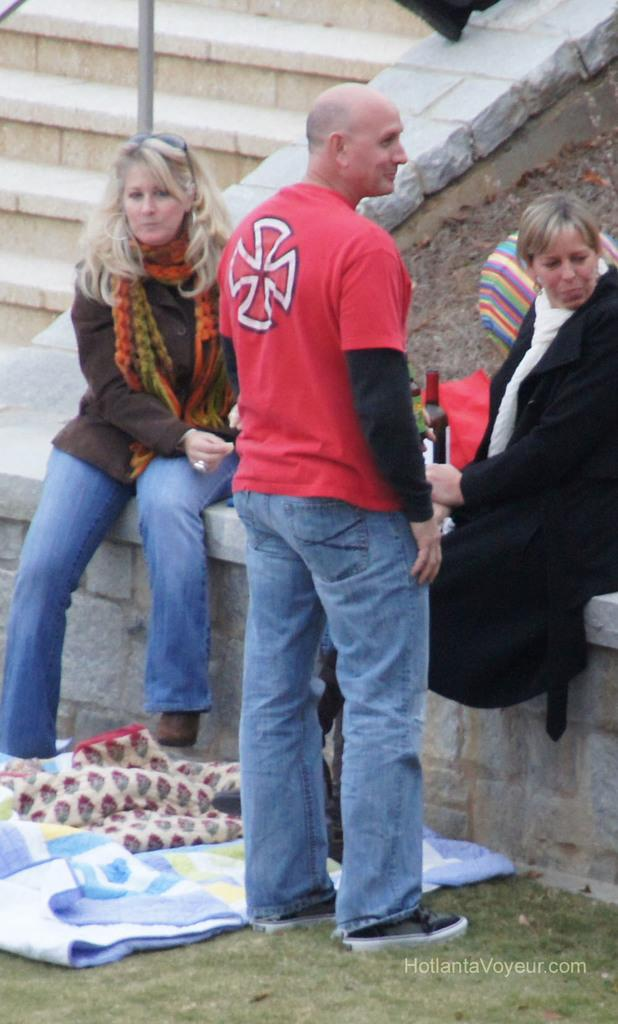What can be seen in the foreground of the picture? There are people and blankets in the foreground of the picture. What architectural feature is located at the top left of the image? There is a staircase, wall, and railing at the top left of the image. What type of paper is being used for payment in the image? There is no paper or payment being depicted in the image. What mark can be seen on the wall at the top left of the image? There is no mark visible on the wall at the top left of the image. 